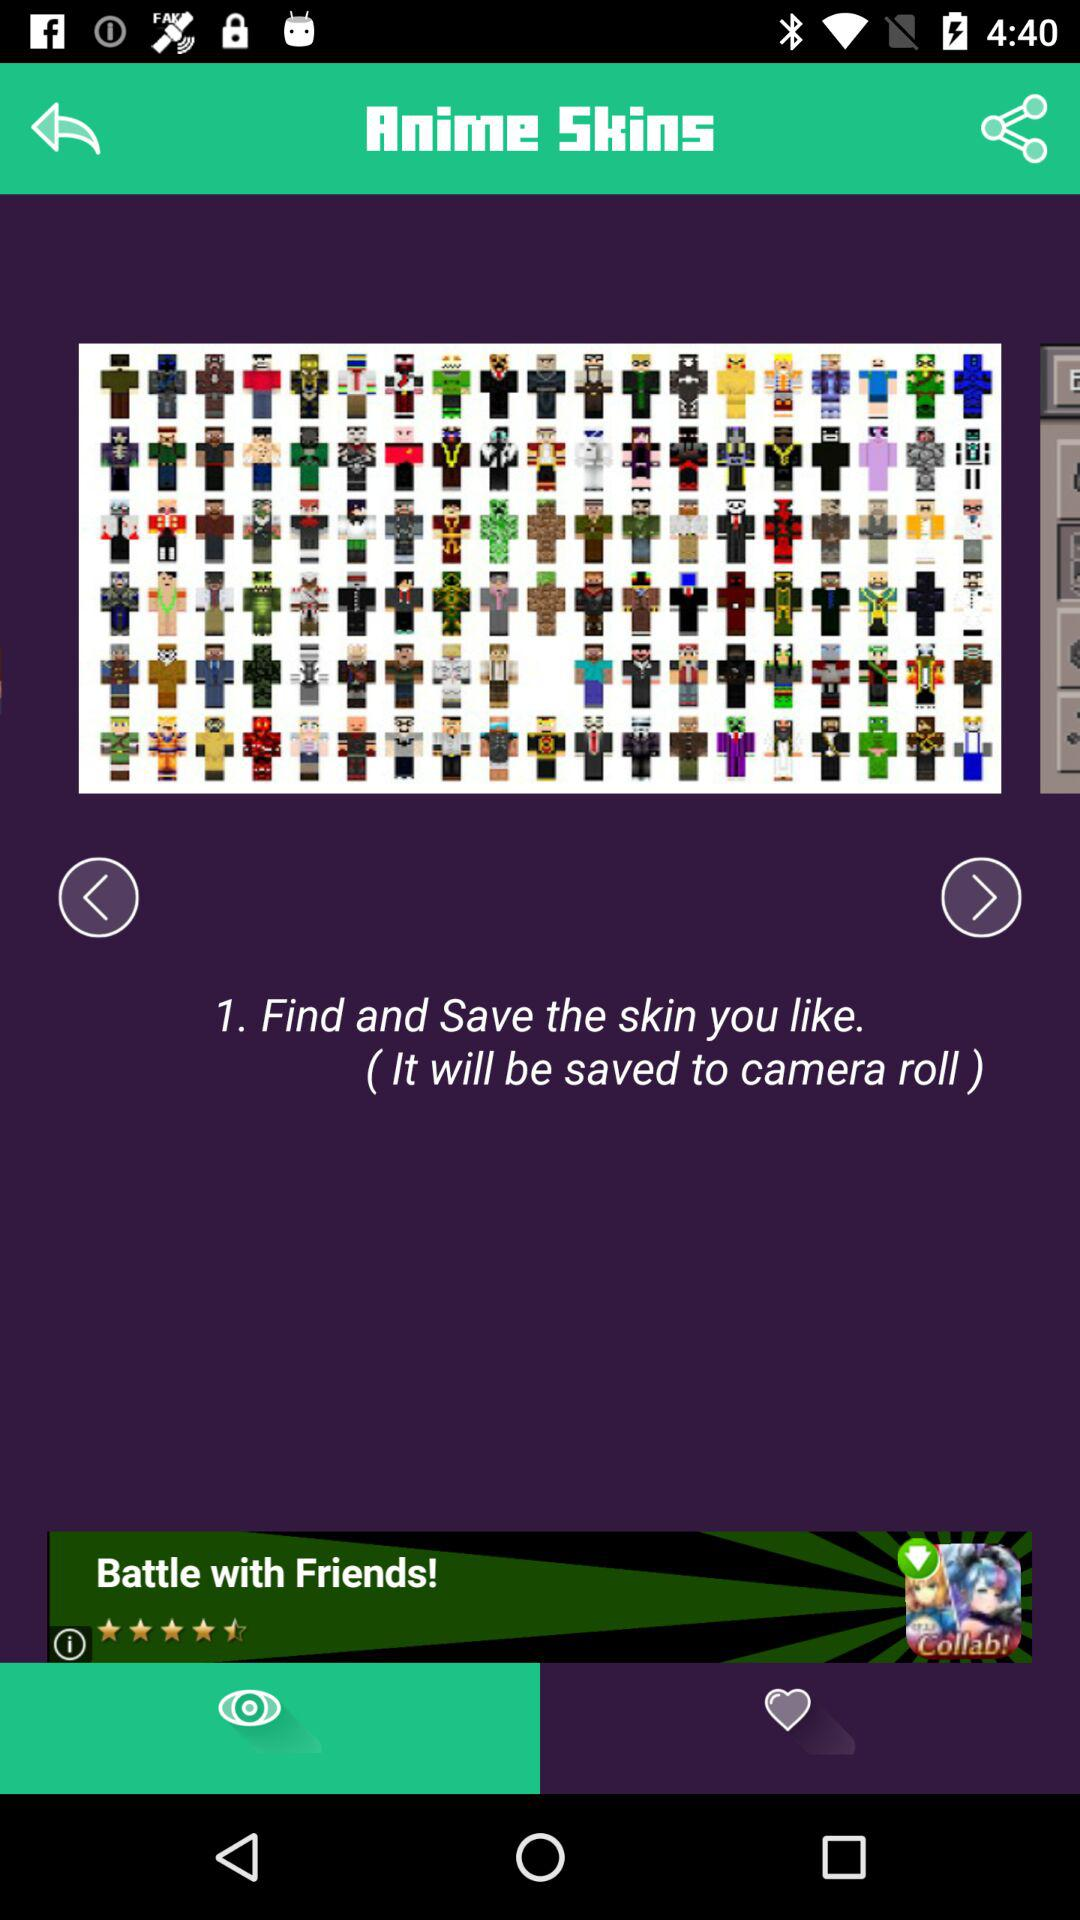Where will the skin be saved? The skin will be saved to camera roll. 